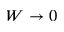<formula> <loc_0><loc_0><loc_500><loc_500>W \to 0</formula> 